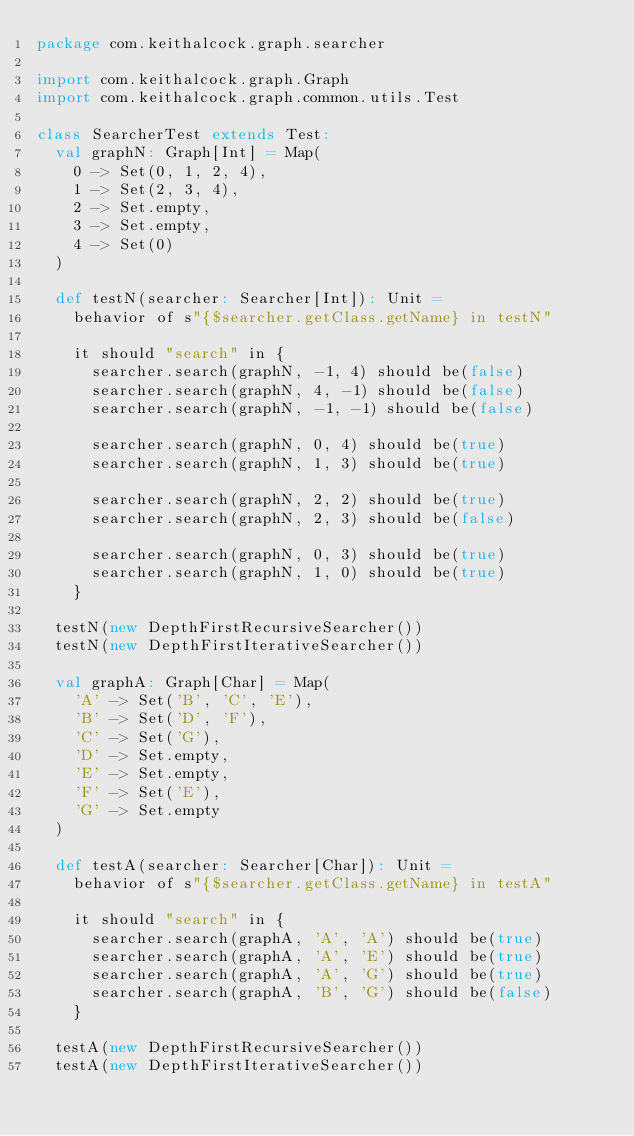Convert code to text. <code><loc_0><loc_0><loc_500><loc_500><_Scala_>package com.keithalcock.graph.searcher

import com.keithalcock.graph.Graph
import com.keithalcock.graph.common.utils.Test

class SearcherTest extends Test:
  val graphN: Graph[Int] = Map(
    0 -> Set(0, 1, 2, 4),
    1 -> Set(2, 3, 4),
    2 -> Set.empty,
    3 -> Set.empty,
    4 -> Set(0)
  )

  def testN(searcher: Searcher[Int]): Unit =
    behavior of s"{$searcher.getClass.getName} in testN"

    it should "search" in {
      searcher.search(graphN, -1, 4) should be(false)
      searcher.search(graphN, 4, -1) should be(false)
      searcher.search(graphN, -1, -1) should be(false)

      searcher.search(graphN, 0, 4) should be(true)
      searcher.search(graphN, 1, 3) should be(true)

      searcher.search(graphN, 2, 2) should be(true)
      searcher.search(graphN, 2, 3) should be(false)

      searcher.search(graphN, 0, 3) should be(true)
      searcher.search(graphN, 1, 0) should be(true)
    }

  testN(new DepthFirstRecursiveSearcher())
  testN(new DepthFirstIterativeSearcher())

  val graphA: Graph[Char] = Map(
    'A' -> Set('B', 'C', 'E'),
    'B' -> Set('D', 'F'),
    'C' -> Set('G'),
    'D' -> Set.empty,
    'E' -> Set.empty,
    'F' -> Set('E'),
    'G' -> Set.empty
  )

  def testA(searcher: Searcher[Char]): Unit =
    behavior of s"{$searcher.getClass.getName} in testA"

    it should "search" in {
      searcher.search(graphA, 'A', 'A') should be(true)
      searcher.search(graphA, 'A', 'E') should be(true)
      searcher.search(graphA, 'A', 'G') should be(true)
      searcher.search(graphA, 'B', 'G') should be(false)
    }

  testA(new DepthFirstRecursiveSearcher())
  testA(new DepthFirstIterativeSearcher())
</code> 